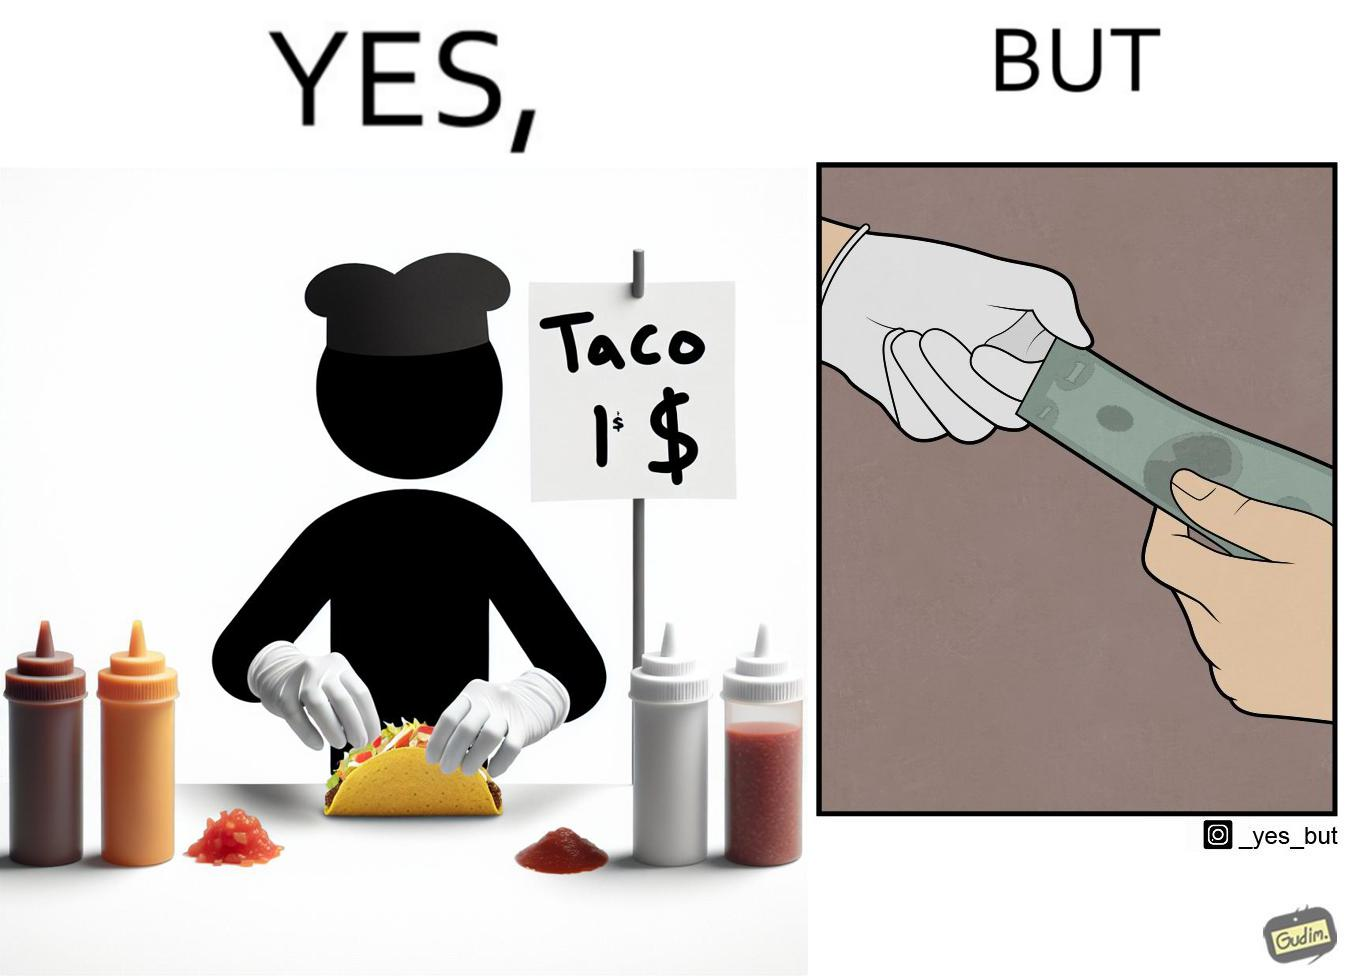Describe what you see in this image. The image is satirical because the intention of wearing a glove while preparing food is to not let any germs and dirt from our hands get into the food, people do other tasks like collecting money from the customer wearing the same gloves and thus making the gloves themselves dirty. 